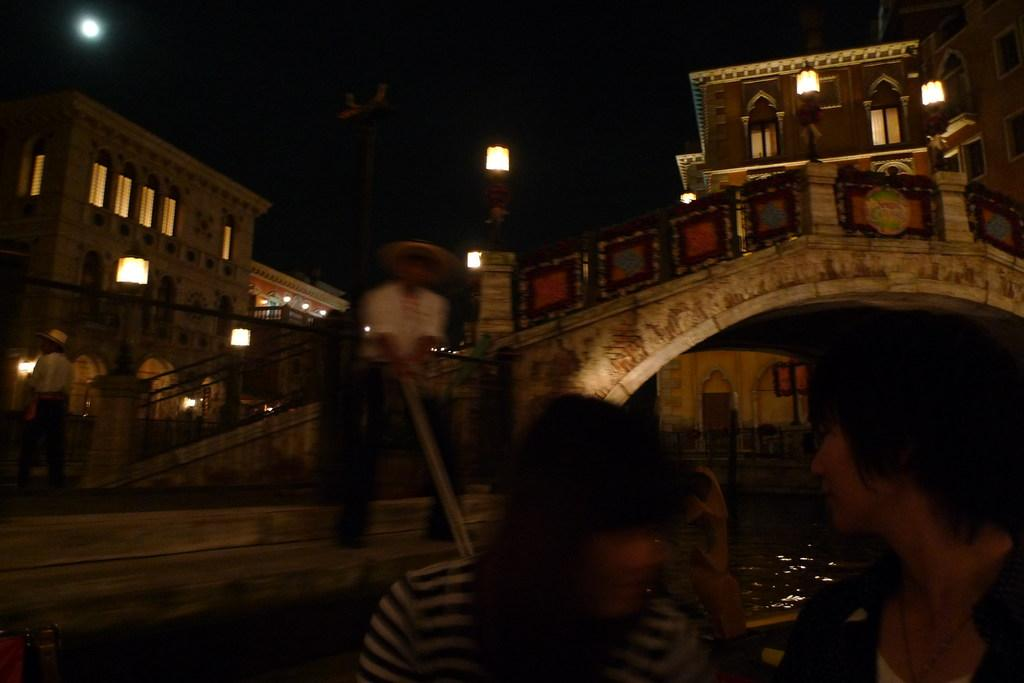What is the main subject of the image? The main subject of the image is a boat. Are there any people on the boat? Yes, people are present on the boat. Where is the boat located? The boat is on the water. What other structures can be seen in the image? There are buildings, stairs, and a bridge in the image. Are there any lighting features in the image? Yes, there are lights in the image. What can be seen in the sky in the image? The moon is present in the sky. How many weeks does it take for the boat to travel the range shown in the image? There is no information about the boat's travel time or distance in the image, so it's not possible to answer this question. Is there an army visible in the image? No, there is no army present in the image. 